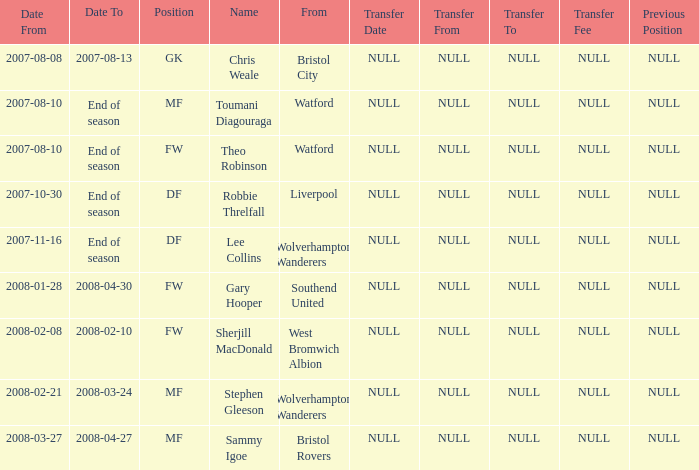What was the starting date for toumani diagouraga, who was an mf player? 2007-08-10. 